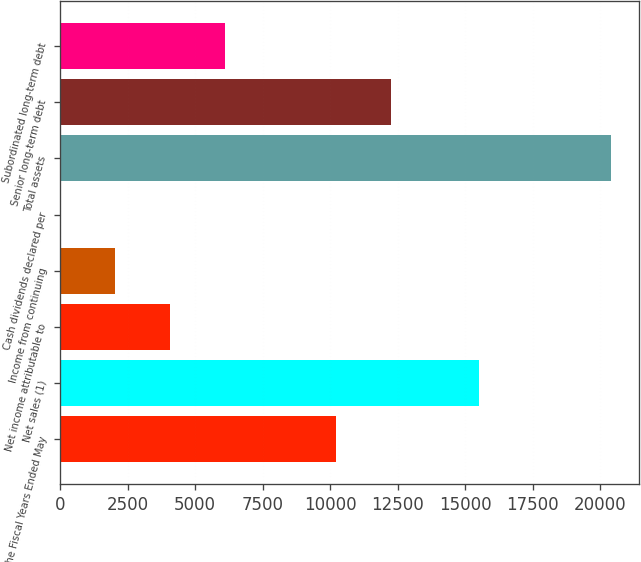Convert chart. <chart><loc_0><loc_0><loc_500><loc_500><bar_chart><fcel>For the Fiscal Years Ended May<fcel>Net sales (1)<fcel>Net income attributable to<fcel>Income from continuing<fcel>Cash dividends declared per<fcel>Total assets<fcel>Senior long-term debt<fcel>Subordinated long-term debt<nl><fcel>10203.1<fcel>15491.4<fcel>4081.85<fcel>2041.42<fcel>0.99<fcel>20405.3<fcel>12243.6<fcel>6122.28<nl></chart> 